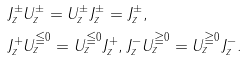Convert formula to latex. <formula><loc_0><loc_0><loc_500><loc_500>& J _ { z } ^ { \pm } U _ { z } ^ { \pm } = U _ { z } ^ { \pm } J _ { z } ^ { \pm } = J _ { z } ^ { \pm } , \\ & J _ { z } ^ { + } U _ { z } ^ { \leqq 0 } = U _ { z } ^ { \leqq 0 } J _ { z } ^ { + } , J _ { z } ^ { - } U _ { z } ^ { \geqq 0 } = U _ { z } ^ { \geqq 0 } J _ { z } ^ { - } .</formula> 